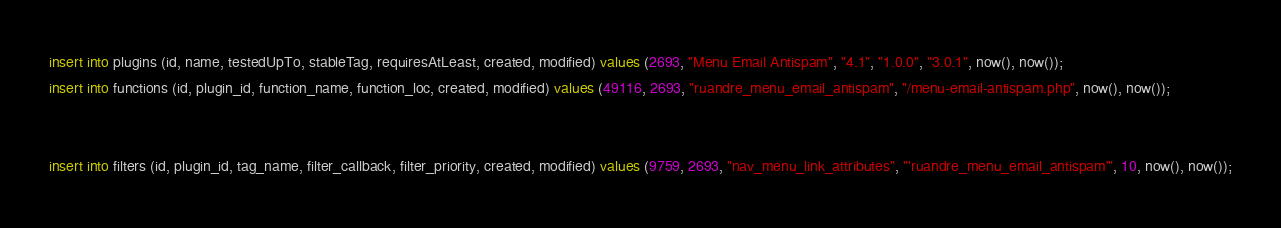<code> <loc_0><loc_0><loc_500><loc_500><_SQL_>insert into plugins (id, name, testedUpTo, stableTag, requiresAtLeast, created, modified) values (2693, "Menu Email Antispam", "4.1", "1.0.0", "3.0.1", now(), now());
insert into functions (id, plugin_id, function_name, function_loc, created, modified) values (49116, 2693, "ruandre_menu_email_antispam", "/menu-email-antispam.php", now(), now());


insert into filters (id, plugin_id, tag_name, filter_callback, filter_priority, created, modified) values (9759, 2693, "nav_menu_link_attributes", "'ruandre_menu_email_antispam'", 10, now(), now());</code> 